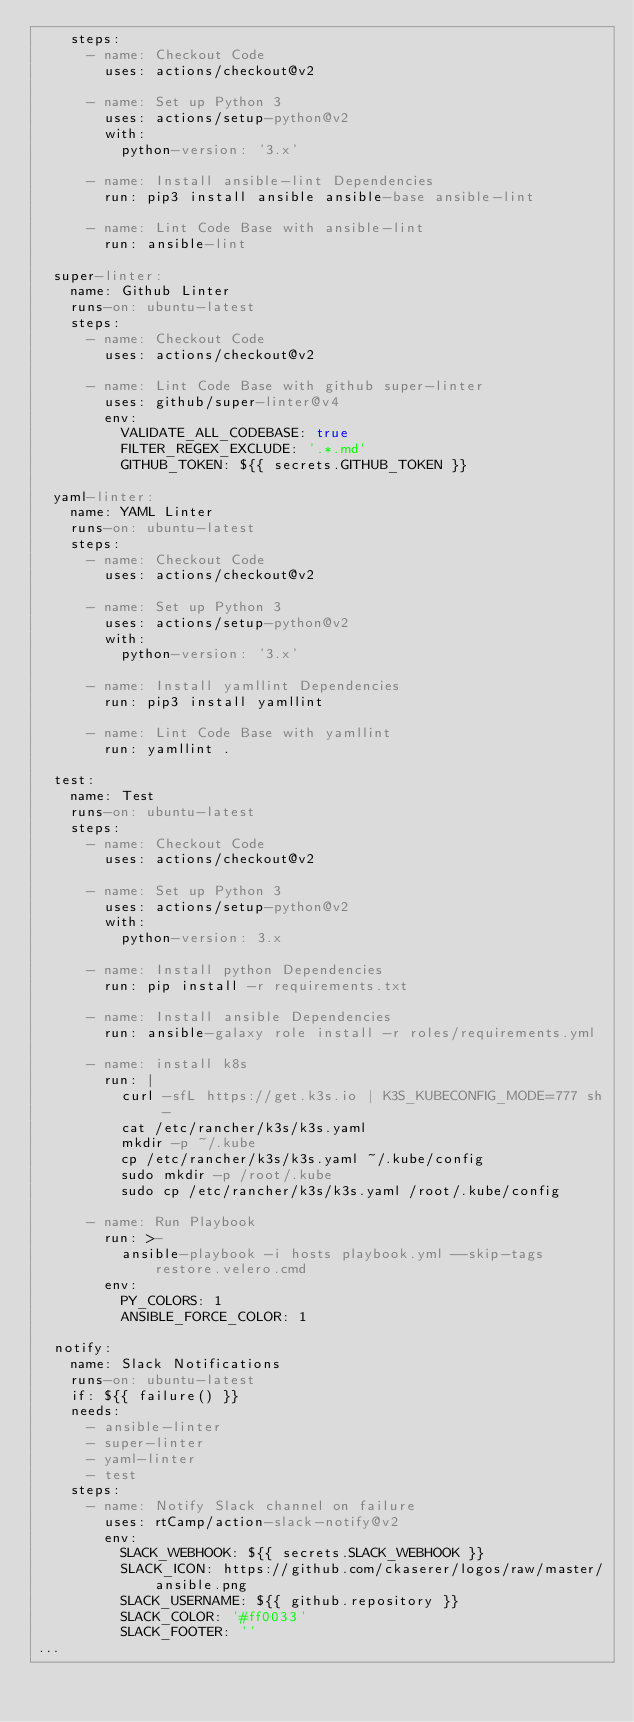Convert code to text. <code><loc_0><loc_0><loc_500><loc_500><_YAML_>    steps:
      - name: Checkout Code
        uses: actions/checkout@v2

      - name: Set up Python 3
        uses: actions/setup-python@v2
        with:
          python-version: '3.x'

      - name: Install ansible-lint Dependencies
        run: pip3 install ansible ansible-base ansible-lint

      - name: Lint Code Base with ansible-lint
        run: ansible-lint

  super-linter:
    name: Github Linter
    runs-on: ubuntu-latest
    steps:
      - name: Checkout Code
        uses: actions/checkout@v2

      - name: Lint Code Base with github super-linter
        uses: github/super-linter@v4
        env:
          VALIDATE_ALL_CODEBASE: true
          FILTER_REGEX_EXCLUDE: '.*.md'
          GITHUB_TOKEN: ${{ secrets.GITHUB_TOKEN }}

  yaml-linter:
    name: YAML Linter
    runs-on: ubuntu-latest
    steps:
      - name: Checkout Code
        uses: actions/checkout@v2

      - name: Set up Python 3
        uses: actions/setup-python@v2
        with:
          python-version: '3.x'

      - name: Install yamllint Dependencies
        run: pip3 install yamllint

      - name: Lint Code Base with yamllint
        run: yamllint .

  test:
    name: Test
    runs-on: ubuntu-latest
    steps:
      - name: Checkout Code
        uses: actions/checkout@v2

      - name: Set up Python 3
        uses: actions/setup-python@v2
        with:
          python-version: 3.x

      - name: Install python Dependencies
        run: pip install -r requirements.txt

      - name: Install ansible Dependencies
        run: ansible-galaxy role install -r roles/requirements.yml

      - name: install k8s
        run: |
          curl -sfL https://get.k3s.io | K3S_KUBECONFIG_MODE=777 sh -
          cat /etc/rancher/k3s/k3s.yaml
          mkdir -p ~/.kube
          cp /etc/rancher/k3s/k3s.yaml ~/.kube/config
          sudo mkdir -p /root/.kube
          sudo cp /etc/rancher/k3s/k3s.yaml /root/.kube/config

      - name: Run Playbook
        run: >-
          ansible-playbook -i hosts playbook.yml --skip-tags restore.velero.cmd
        env:
          PY_COLORS: 1
          ANSIBLE_FORCE_COLOR: 1

  notify:
    name: Slack Notifications
    runs-on: ubuntu-latest
    if: ${{ failure() }}
    needs:
      - ansible-linter
      - super-linter
      - yaml-linter
      - test
    steps:
      - name: Notify Slack channel on failure
        uses: rtCamp/action-slack-notify@v2
        env:
          SLACK_WEBHOOK: ${{ secrets.SLACK_WEBHOOK }}
          SLACK_ICON: https://github.com/ckaserer/logos/raw/master/ansible.png
          SLACK_USERNAME: ${{ github.repository }}
          SLACK_COLOR: '#ff0033'
          SLACK_FOOTER: ''
...
</code> 